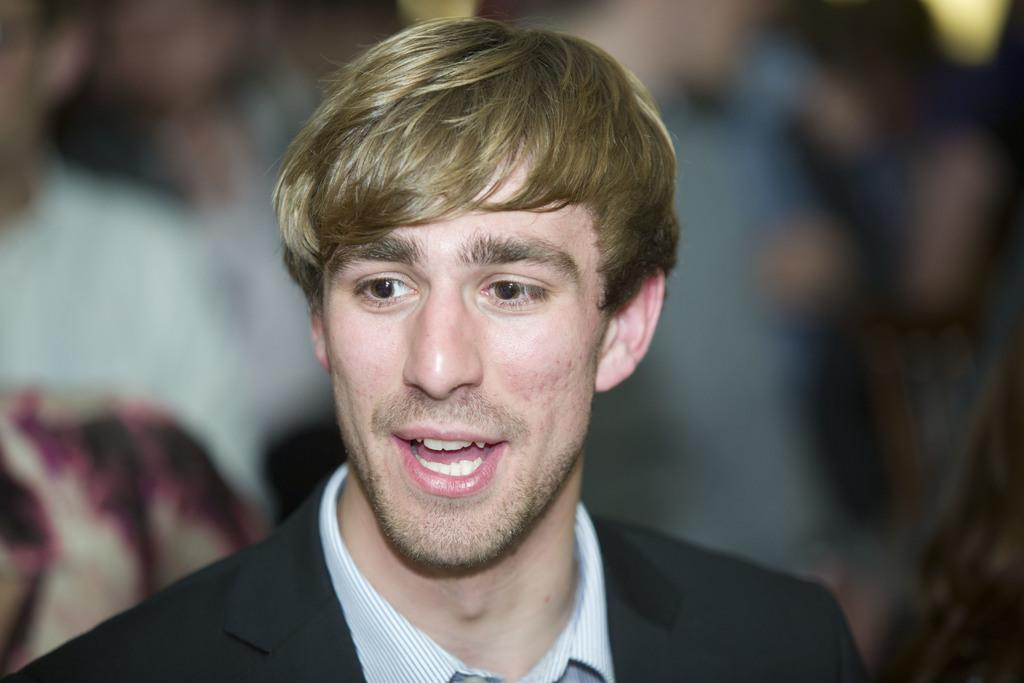What is the main subject of the image? The main subject of the image is a man. What is the man doing in the image? The man is standing in the image. What is the man's facial expression in the image? The man is smiling in the image. What is the man wearing in the image? The man is wearing a black color blazer in the image. What can be seen in the background of the image? There are people in the background of the image. How many cars can be seen in the image? There are no cars present in the image; it features a man standing and smiling while wearing a black blazer. Is there a drain visible in the image? There is no drain present in the image. 